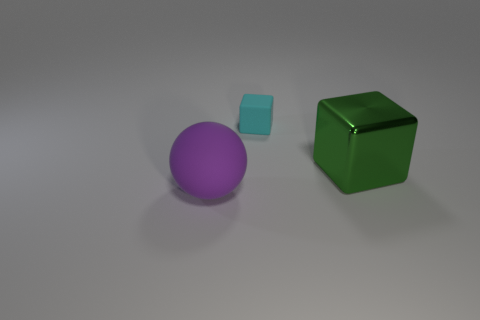Is there any other thing that is made of the same material as the green object?
Your answer should be compact. No. What number of things are either large rubber balls or blocks that are in front of the small cyan cube?
Provide a succinct answer. 2. What number of other objects are there of the same size as the purple matte thing?
Keep it short and to the point. 1. Are the large thing that is to the right of the large purple sphere and the object to the left of the tiny rubber cube made of the same material?
Provide a succinct answer. No. There is a green shiny block; what number of purple matte balls are in front of it?
Make the answer very short. 1. What number of red things are large things or large matte balls?
Provide a succinct answer. 0. What is the material of the object that is the same size as the purple rubber sphere?
Your answer should be compact. Metal. There is a object that is in front of the tiny cyan rubber thing and to the left of the big green metal cube; what shape is it?
Ensure brevity in your answer.  Sphere. What color is the thing that is the same size as the rubber ball?
Offer a very short reply. Green. There is a block behind the big cube; does it have the same size as the block that is in front of the tiny cyan object?
Provide a succinct answer. No. 